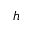<formula> <loc_0><loc_0><loc_500><loc_500>h</formula> 